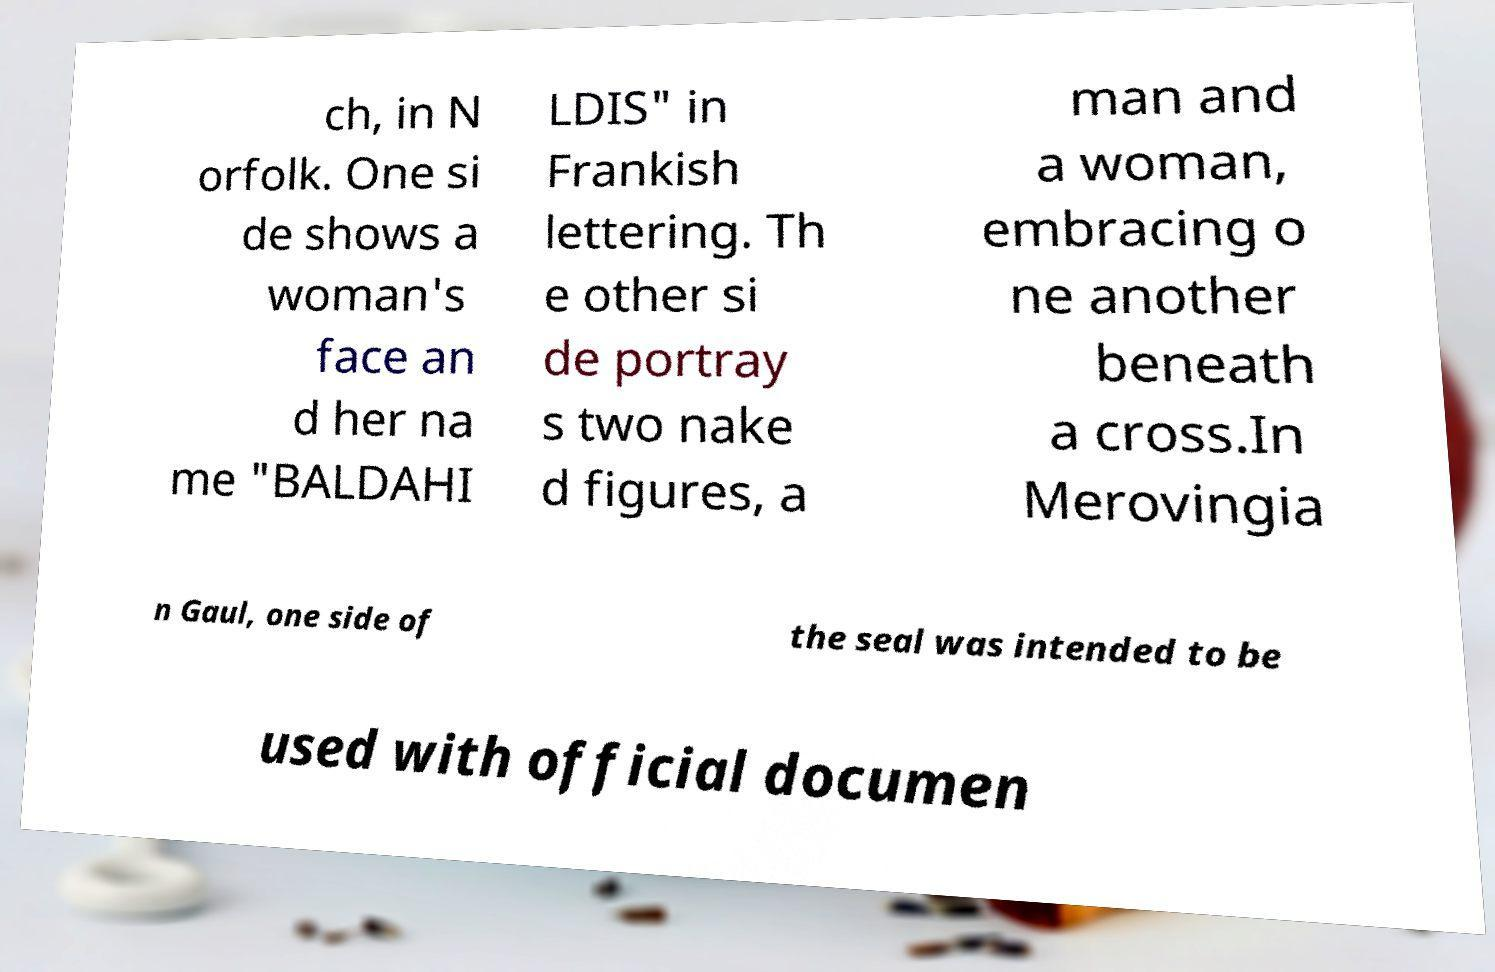Could you extract and type out the text from this image? ch, in N orfolk. One si de shows a woman's face an d her na me "BALDAHI LDIS" in Frankish lettering. Th e other si de portray s two nake d figures, a man and a woman, embracing o ne another beneath a cross.In Merovingia n Gaul, one side of the seal was intended to be used with official documen 